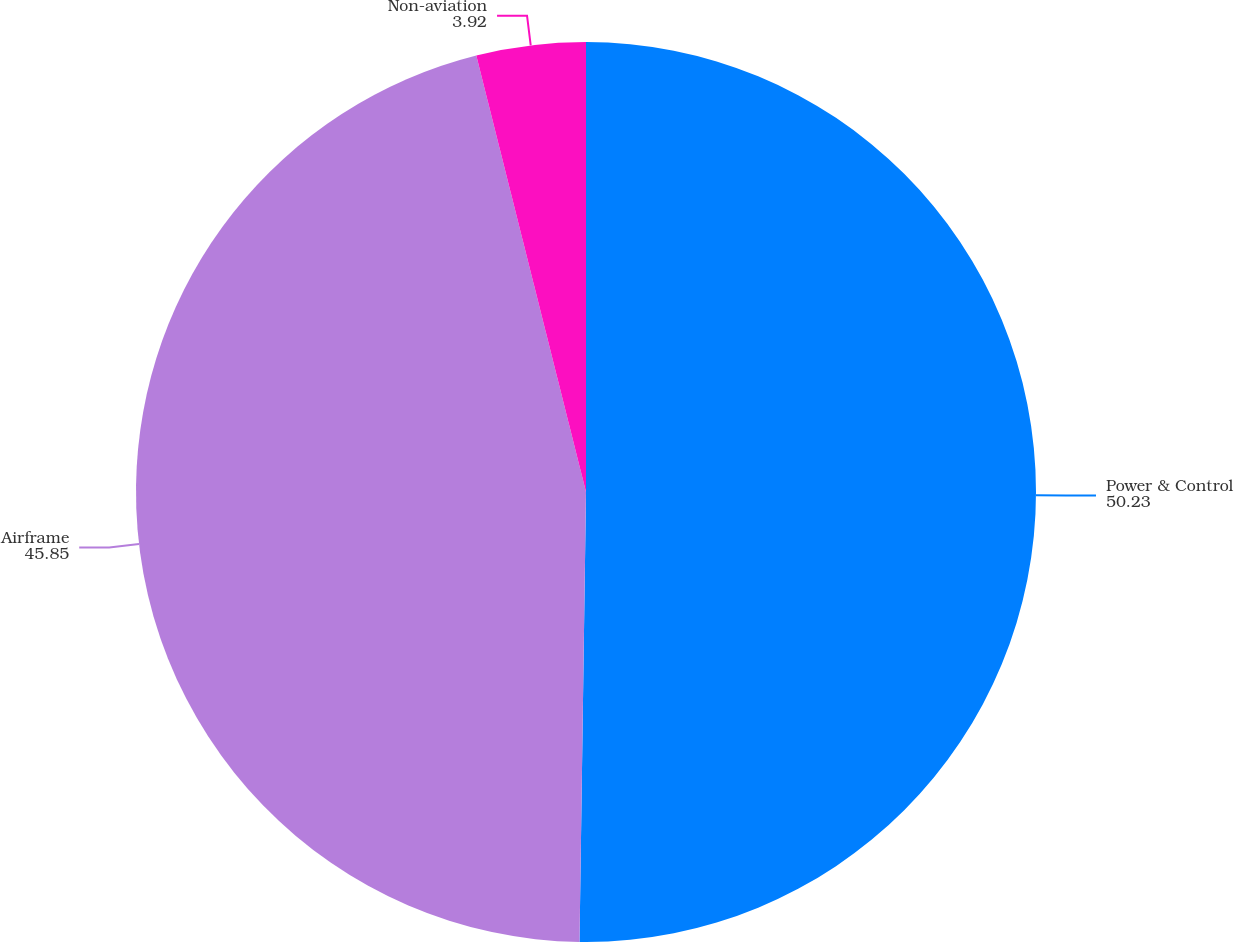<chart> <loc_0><loc_0><loc_500><loc_500><pie_chart><fcel>Power & Control<fcel>Airframe<fcel>Non-aviation<nl><fcel>50.23%<fcel>45.85%<fcel>3.92%<nl></chart> 